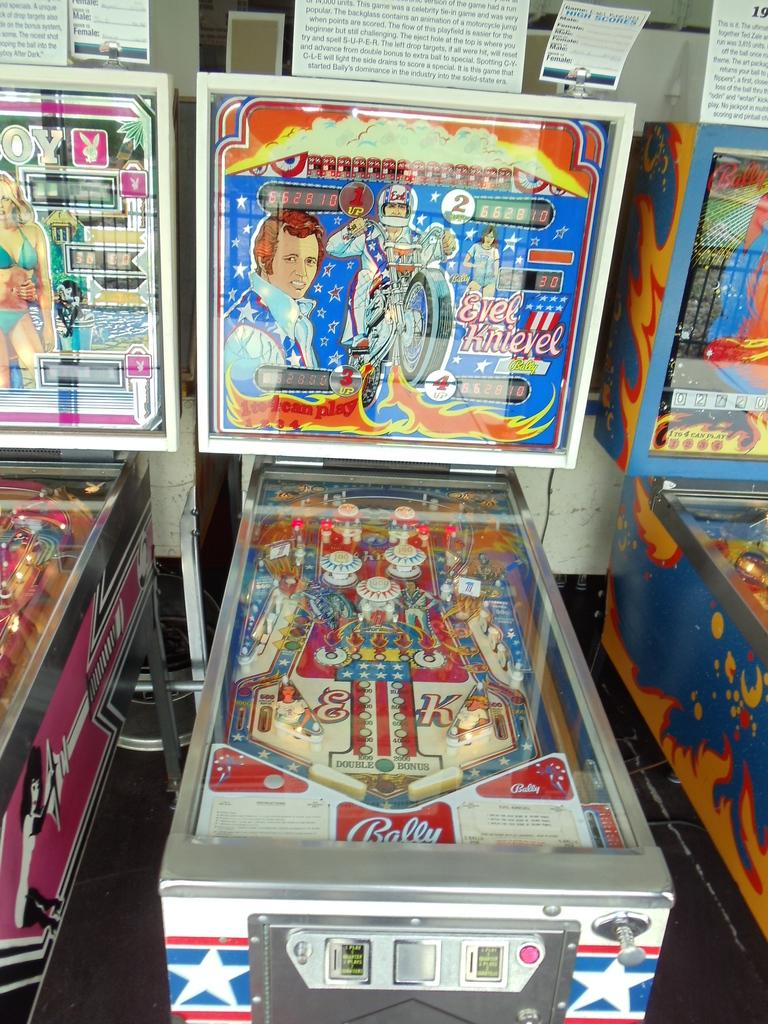<image>
Summarize the visual content of the image. An Evel Knievel pinball machine has the brand Bally printed near the controls. 